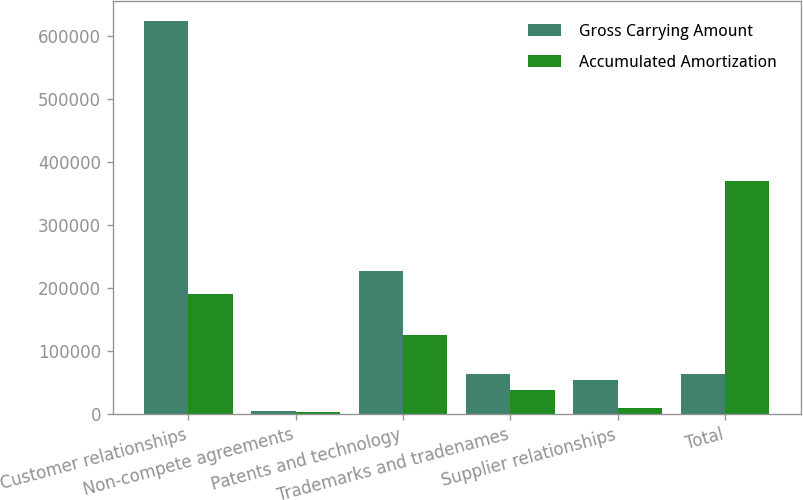Convert chart to OTSL. <chart><loc_0><loc_0><loc_500><loc_500><stacked_bar_chart><ecel><fcel>Customer relationships<fcel>Non-compete agreements<fcel>Patents and technology<fcel>Trademarks and tradenames<fcel>Supplier relationships<fcel>Total<nl><fcel>Gross Carrying Amount<fcel>623774<fcel>4693<fcel>226520<fcel>63570<fcel>54800<fcel>63570<nl><fcel>Accumulated Amortization<fcel>189752<fcel>3945<fcel>126149<fcel>38850<fcel>10047<fcel>368743<nl></chart> 